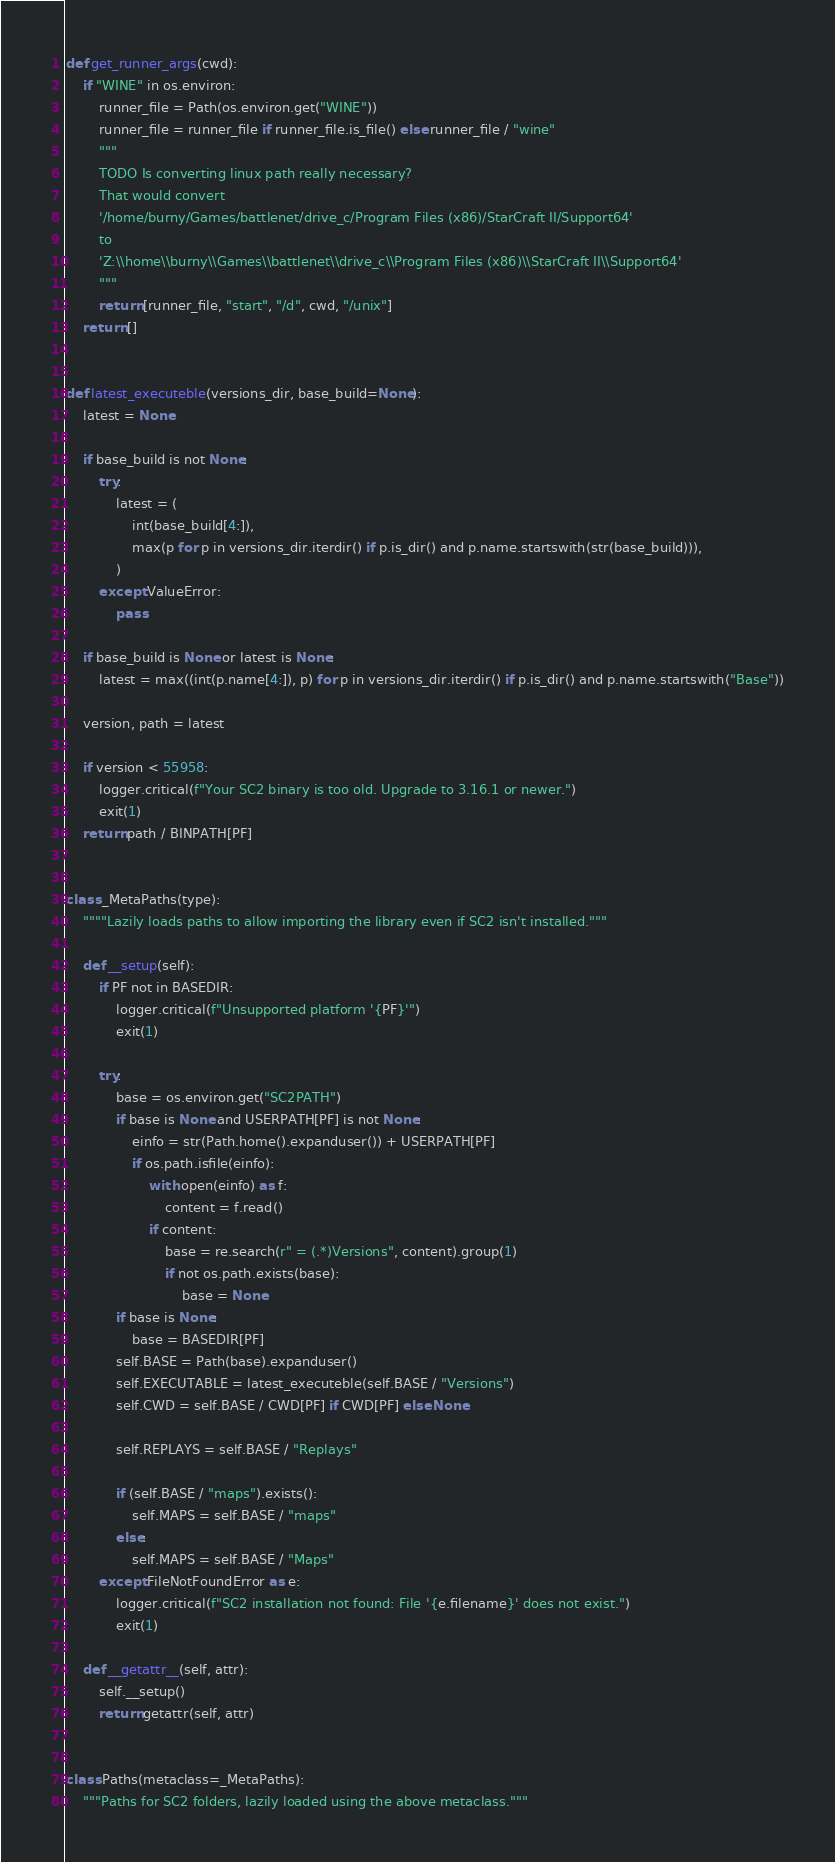<code> <loc_0><loc_0><loc_500><loc_500><_Python_>
def get_runner_args(cwd):
    if "WINE" in os.environ:
        runner_file = Path(os.environ.get("WINE"))
        runner_file = runner_file if runner_file.is_file() else runner_file / "wine"
        """
        TODO Is converting linux path really necessary?
        That would convert 
        '/home/burny/Games/battlenet/drive_c/Program Files (x86)/StarCraft II/Support64'
        to 
        'Z:\\home\\burny\\Games\\battlenet\\drive_c\\Program Files (x86)\\StarCraft II\\Support64'
        """
        return [runner_file, "start", "/d", cwd, "/unix"]
    return []


def latest_executeble(versions_dir, base_build=None):
    latest = None

    if base_build is not None:
        try:
            latest = (
                int(base_build[4:]),
                max(p for p in versions_dir.iterdir() if p.is_dir() and p.name.startswith(str(base_build))),
            )
        except ValueError:
            pass

    if base_build is None or latest is None:
        latest = max((int(p.name[4:]), p) for p in versions_dir.iterdir() if p.is_dir() and p.name.startswith("Base"))

    version, path = latest

    if version < 55958:
        logger.critical(f"Your SC2 binary is too old. Upgrade to 3.16.1 or newer.")
        exit(1)
    return path / BINPATH[PF]


class _MetaPaths(type):
    """"Lazily loads paths to allow importing the library even if SC2 isn't installed."""

    def __setup(self):
        if PF not in BASEDIR:
            logger.critical(f"Unsupported platform '{PF}'")
            exit(1)

        try:
            base = os.environ.get("SC2PATH")
            if base is None and USERPATH[PF] is not None:
                einfo = str(Path.home().expanduser()) + USERPATH[PF]
                if os.path.isfile(einfo):
                    with open(einfo) as f:
                        content = f.read()
                    if content:
                        base = re.search(r" = (.*)Versions", content).group(1)
                        if not os.path.exists(base):
                            base = None
            if base is None:
                base = BASEDIR[PF]
            self.BASE = Path(base).expanduser()
            self.EXECUTABLE = latest_executeble(self.BASE / "Versions")
            self.CWD = self.BASE / CWD[PF] if CWD[PF] else None

            self.REPLAYS = self.BASE / "Replays"

            if (self.BASE / "maps").exists():
                self.MAPS = self.BASE / "maps"
            else:
                self.MAPS = self.BASE / "Maps"
        except FileNotFoundError as e:
            logger.critical(f"SC2 installation not found: File '{e.filename}' does not exist.")
            exit(1)

    def __getattr__(self, attr):
        self.__setup()
        return getattr(self, attr)


class Paths(metaclass=_MetaPaths):
    """Paths for SC2 folders, lazily loaded using the above metaclass."""
</code> 